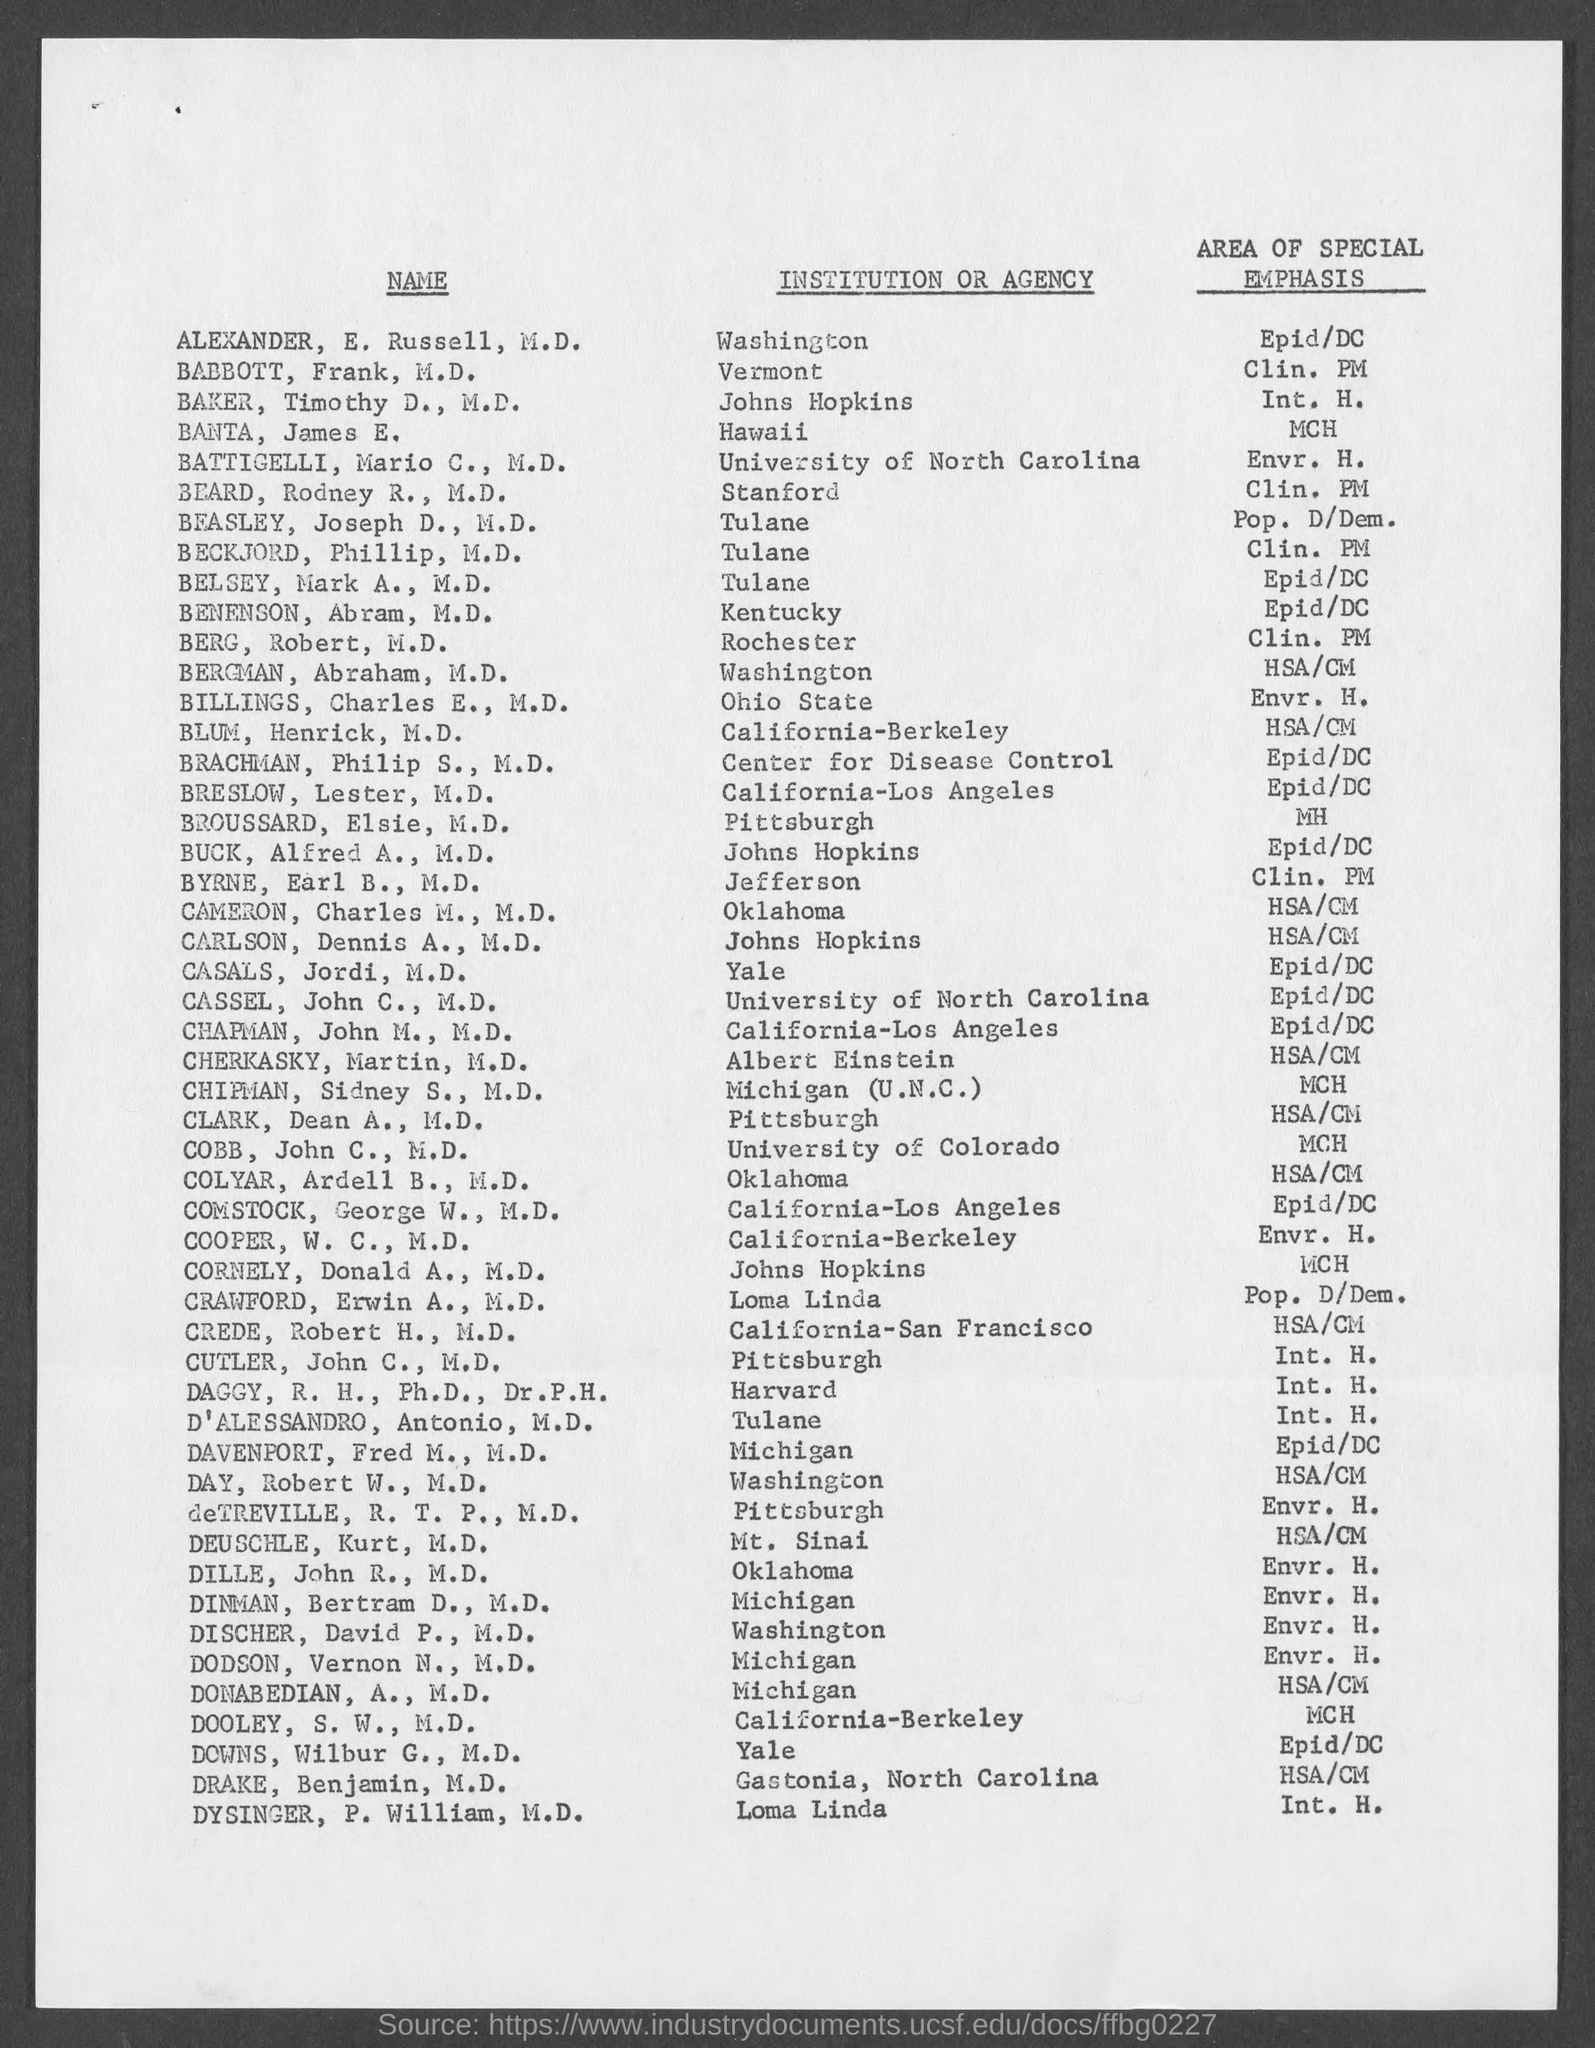List a handful of essential elements in this visual. Alexander E. Russell, M.D. is affiliated with an institution or agency in Washington. James E. Banta, who has a special emphasis on MCH, is from Hawaii. 